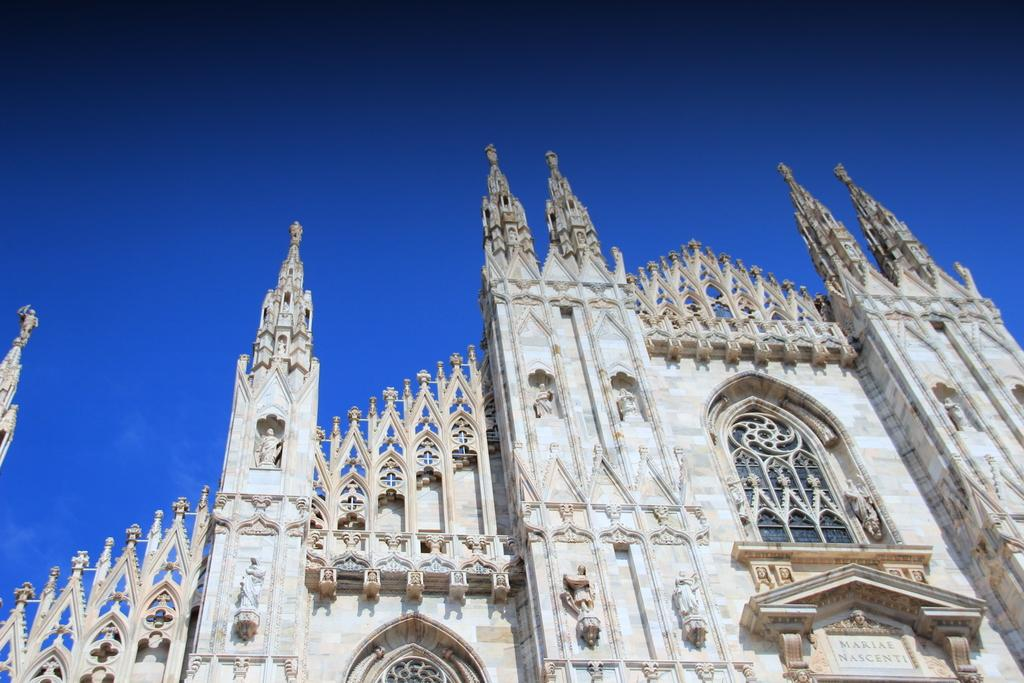What type of structure is the main subject of the image? There is a castle in the image. Can you describe the castle's appearance? The castle's appearance cannot be described in detail based on the provided facts, but it is the main subject of the image. Are there any other structures or objects visible in the image? No additional structures or objects are mentioned in the provided facts, so it can be assumed that the castle is the only visible subject. What type of pain is the castle experiencing in the image? There is no indication of pain in the image, as castles are inanimate objects and cannot experience pain. 